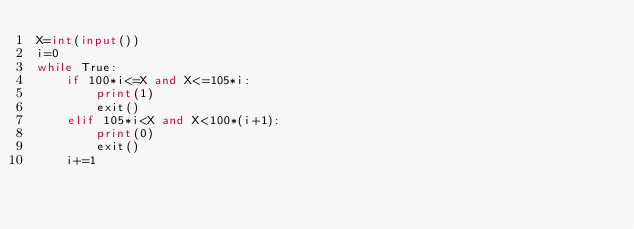Convert code to text. <code><loc_0><loc_0><loc_500><loc_500><_Python_>X=int(input())
i=0
while True:
    if 100*i<=X and X<=105*i:
        print(1)
        exit()
    elif 105*i<X and X<100*(i+1):
        print(0)
        exit()
    i+=1
</code> 